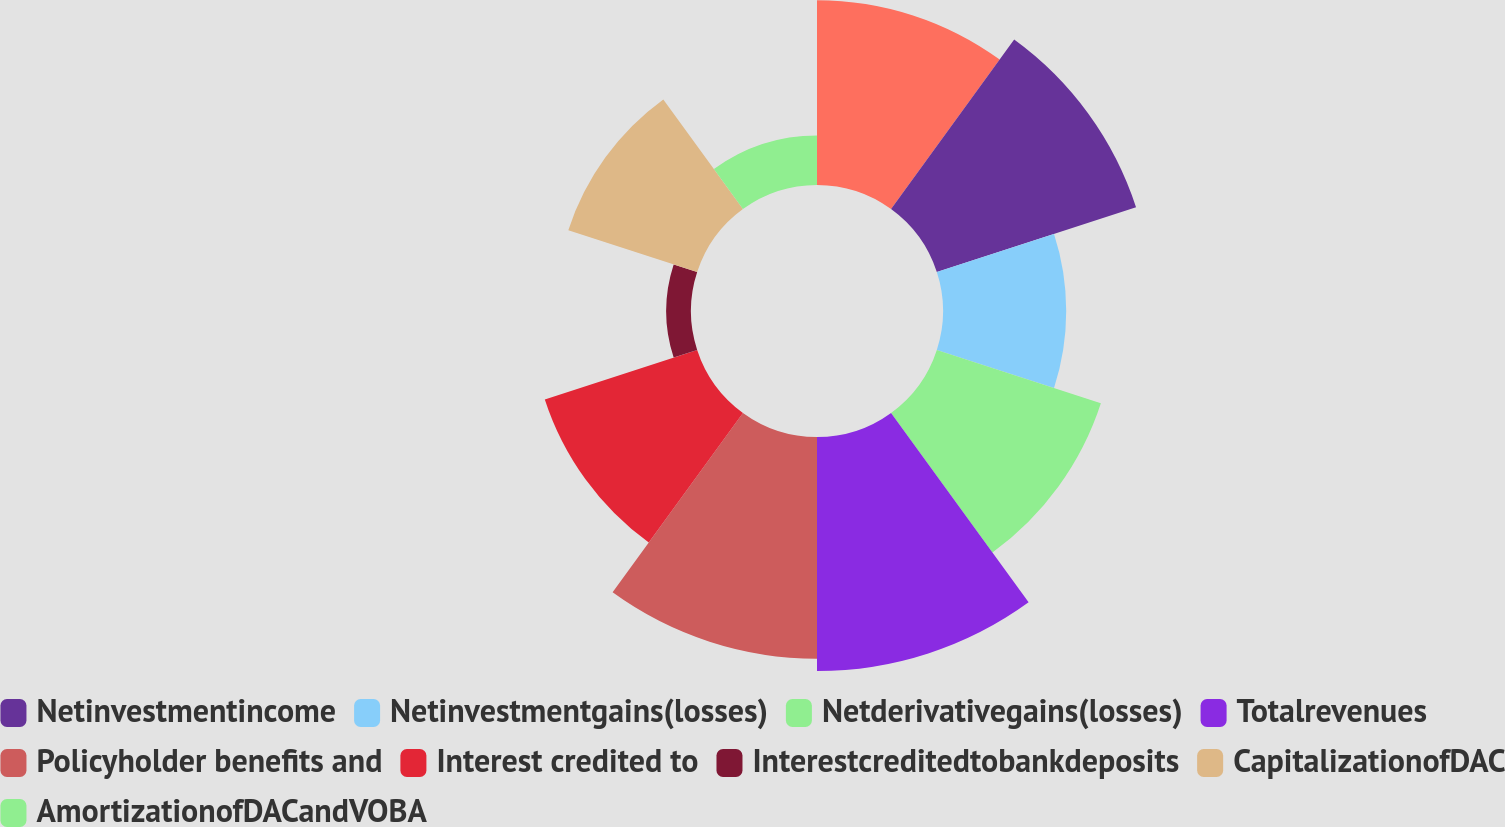Convert chart to OTSL. <chart><loc_0><loc_0><loc_500><loc_500><pie_chart><ecel><fcel>Netinvestmentincome<fcel>Netinvestmentgains(losses)<fcel>Netderivativegains(losses)<fcel>Totalrevenues<fcel>Policyholder benefits and<fcel>Interest credited to<fcel>Interestcreditedtobankdeposits<fcel>CapitalizationofDAC<fcel>AmortizationofDACandVOBA<nl><fcel>12.19%<fcel>13.82%<fcel>8.13%<fcel>11.38%<fcel>15.44%<fcel>14.63%<fcel>10.57%<fcel>1.63%<fcel>8.94%<fcel>3.26%<nl></chart> 